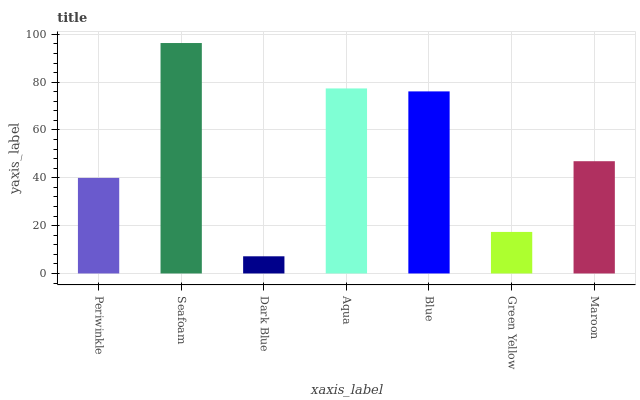Is Dark Blue the minimum?
Answer yes or no. Yes. Is Seafoam the maximum?
Answer yes or no. Yes. Is Seafoam the minimum?
Answer yes or no. No. Is Dark Blue the maximum?
Answer yes or no. No. Is Seafoam greater than Dark Blue?
Answer yes or no. Yes. Is Dark Blue less than Seafoam?
Answer yes or no. Yes. Is Dark Blue greater than Seafoam?
Answer yes or no. No. Is Seafoam less than Dark Blue?
Answer yes or no. No. Is Maroon the high median?
Answer yes or no. Yes. Is Maroon the low median?
Answer yes or no. Yes. Is Dark Blue the high median?
Answer yes or no. No. Is Blue the low median?
Answer yes or no. No. 